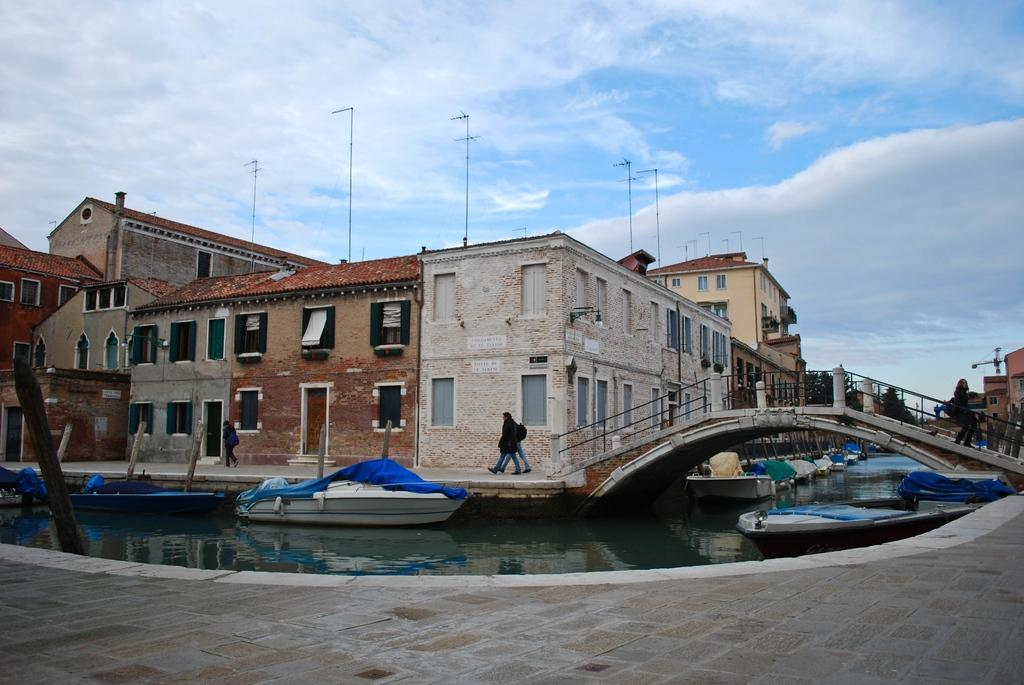What is on the water in the image? There are boats on the water in the image. What structure can be seen in the image? There is a bridge in the image. Who or what is present near the bridge? There is a group of people standing in the image. What type of buildings can be seen in the image? There are houses in the image. What type of vegetation is present in the image? There are trees in the image. What is visible in the background of the image? The sky is visible in the background of the image. What year is the committee meeting taking place in the image? There is no mention of a committee or a meeting in the image, so it is not possible to determine the year. 